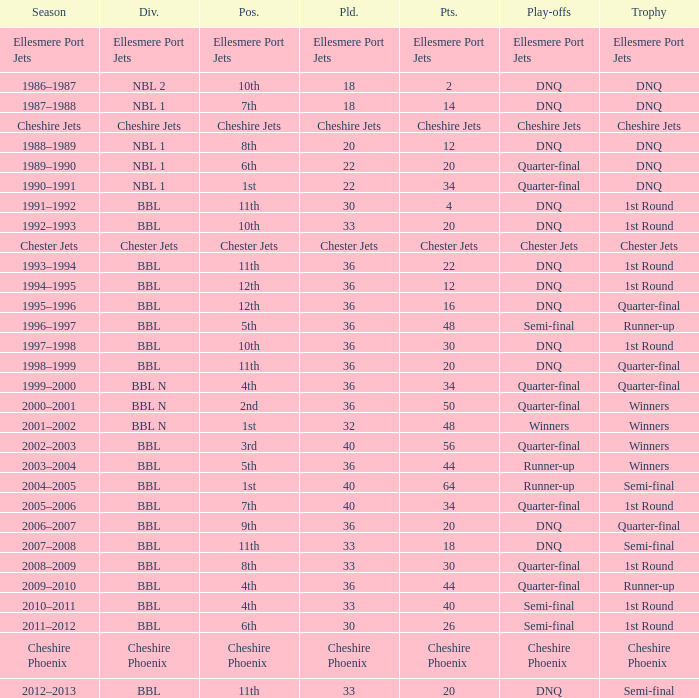During the play-off quarter-final which team scored position was the team that scored 56 points? 3rd. 